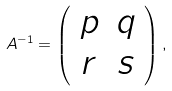<formula> <loc_0><loc_0><loc_500><loc_500>A ^ { - 1 } = \left ( \begin{array} { c c } p & q \\ r & s \end{array} \right ) ,</formula> 